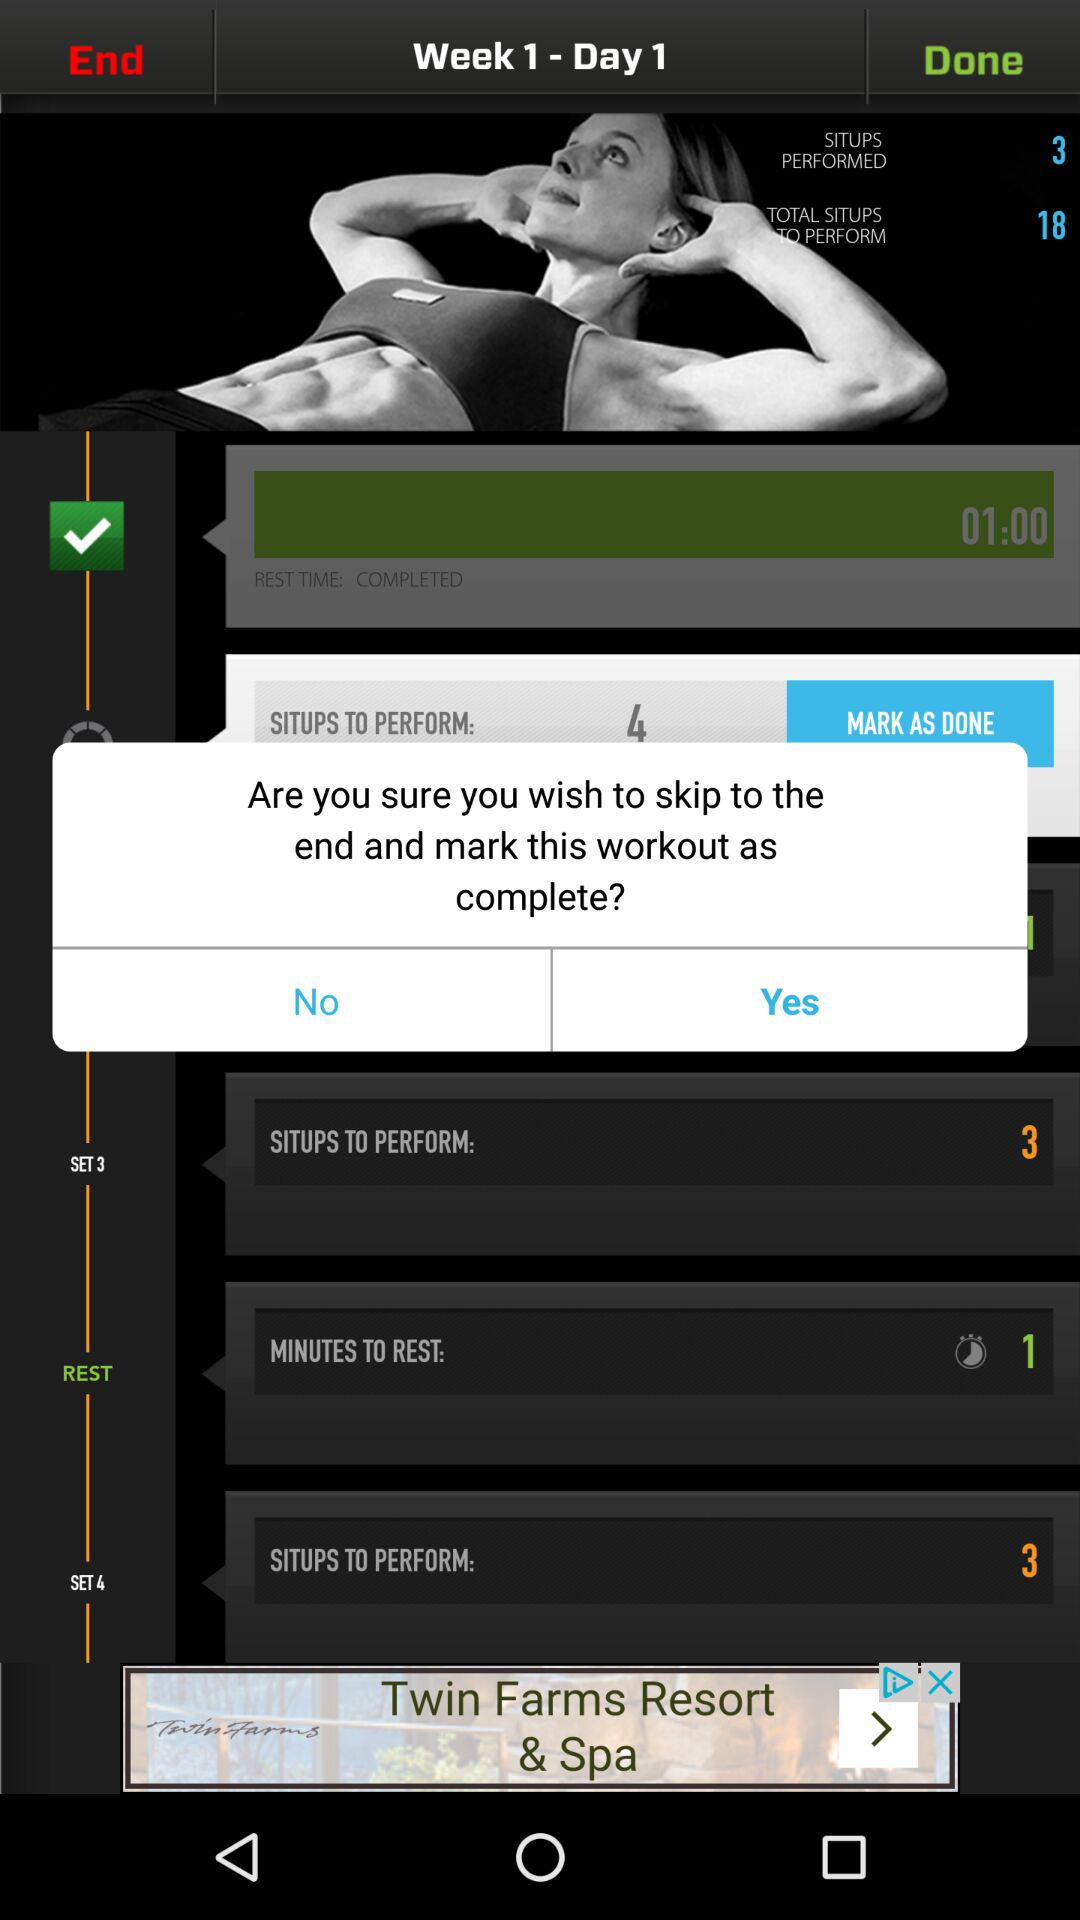How many situps did I perform?
Answer the question using a single word or phrase. 3 